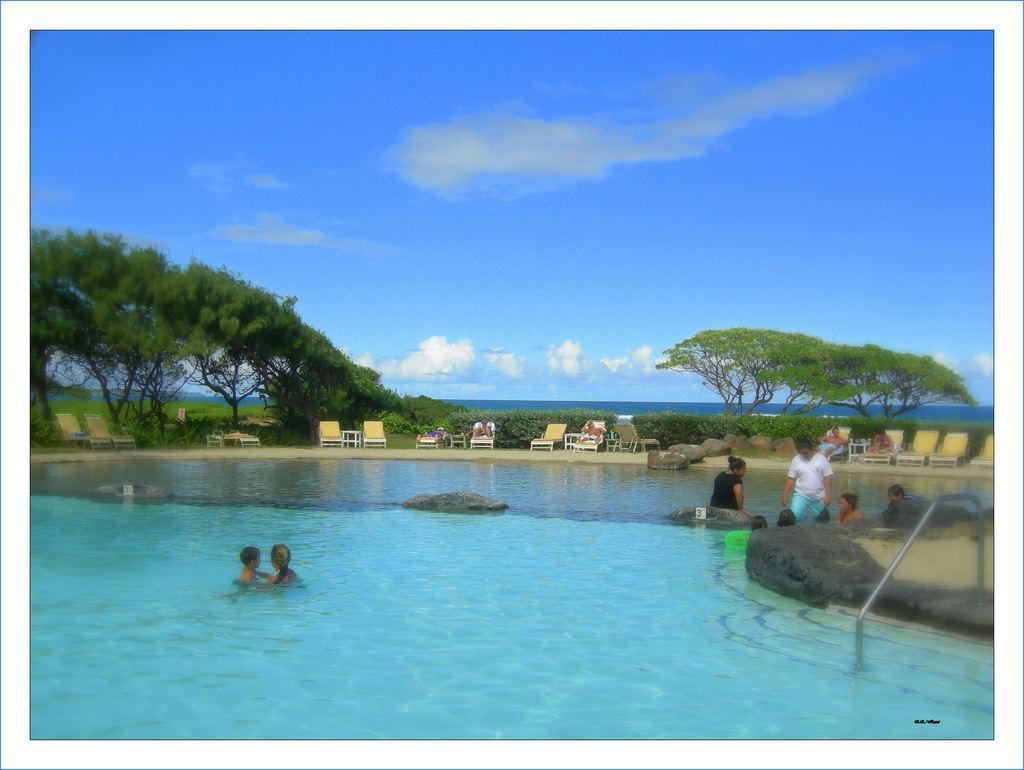Please provide a concise description of this image. In this image, there are a few people. Among them, some people are in the water. We can also see a metal object. There are a few chairs, trees, plants. We can see the ground with some grass. We can also see the sky with clouds. 